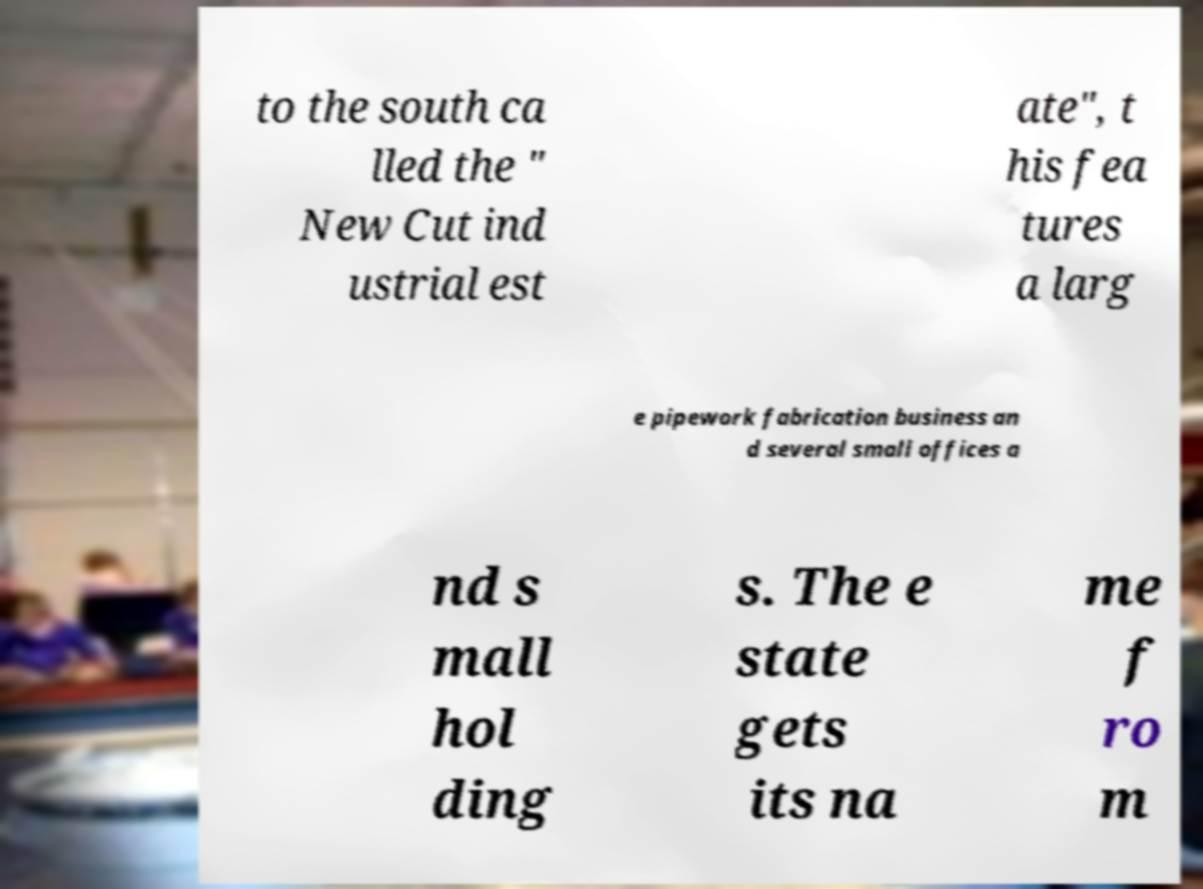Please identify and transcribe the text found in this image. to the south ca lled the " New Cut ind ustrial est ate", t his fea tures a larg e pipework fabrication business an d several small offices a nd s mall hol ding s. The e state gets its na me f ro m 